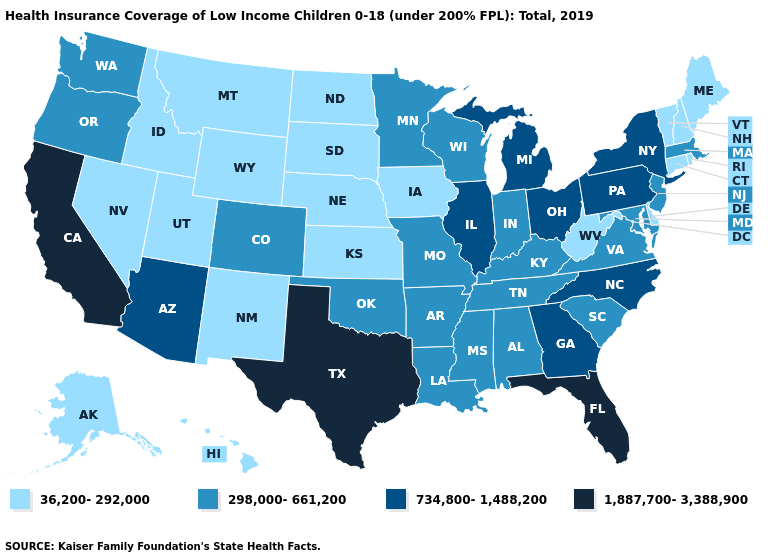Which states have the highest value in the USA?
Answer briefly. California, Florida, Texas. Does Mississippi have the lowest value in the USA?
Answer briefly. No. Among the states that border Indiana , does Kentucky have the highest value?
Keep it brief. No. Name the states that have a value in the range 298,000-661,200?
Keep it brief. Alabama, Arkansas, Colorado, Indiana, Kentucky, Louisiana, Maryland, Massachusetts, Minnesota, Mississippi, Missouri, New Jersey, Oklahoma, Oregon, South Carolina, Tennessee, Virginia, Washington, Wisconsin. Which states have the lowest value in the USA?
Give a very brief answer. Alaska, Connecticut, Delaware, Hawaii, Idaho, Iowa, Kansas, Maine, Montana, Nebraska, Nevada, New Hampshire, New Mexico, North Dakota, Rhode Island, South Dakota, Utah, Vermont, West Virginia, Wyoming. How many symbols are there in the legend?
Write a very short answer. 4. What is the lowest value in the MidWest?
Answer briefly. 36,200-292,000. Does Delaware have the lowest value in the South?
Quick response, please. Yes. Does the first symbol in the legend represent the smallest category?
Keep it brief. Yes. What is the value of Mississippi?
Concise answer only. 298,000-661,200. What is the highest value in the MidWest ?
Concise answer only. 734,800-1,488,200. What is the value of Connecticut?
Give a very brief answer. 36,200-292,000. Among the states that border Ohio , which have the highest value?
Keep it brief. Michigan, Pennsylvania. Name the states that have a value in the range 734,800-1,488,200?
Short answer required. Arizona, Georgia, Illinois, Michigan, New York, North Carolina, Ohio, Pennsylvania. 